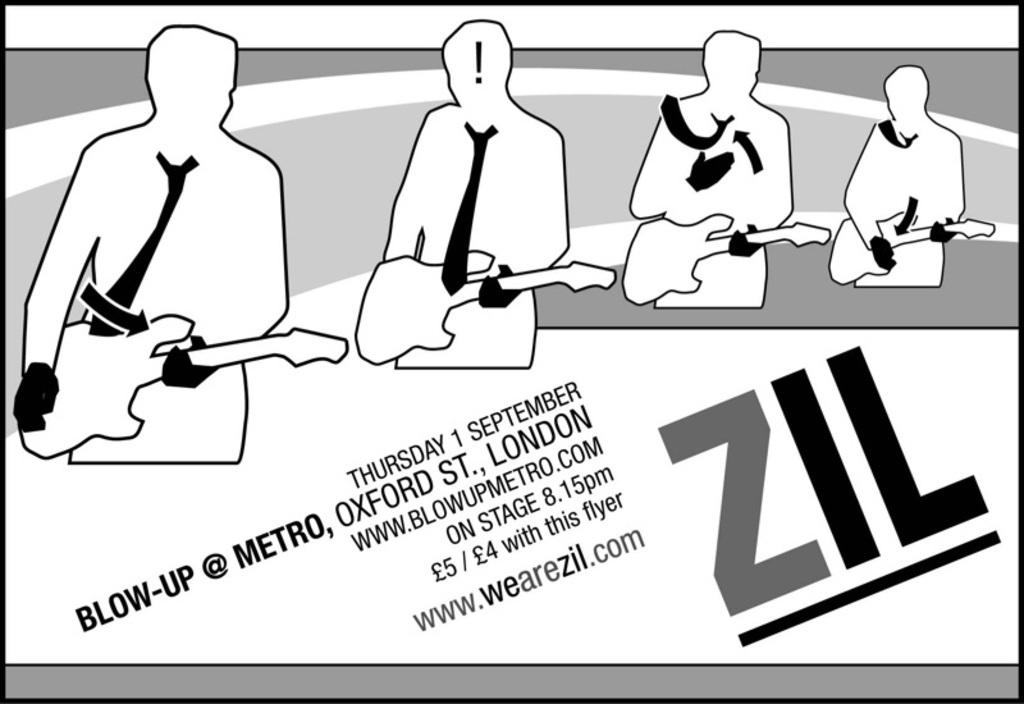What type of image is being described? The image is animated. What can be seen in the animated image? There are depictions of people in the image. Are there any words or letters in the image? Yes, there is text present in the image. How many houses are visible in the image? There are no houses present in the image; it features animated depictions of people and text. What type of screw is being used by the people in the image? There is no screw present in the image; it is an animated depiction of people and text. 